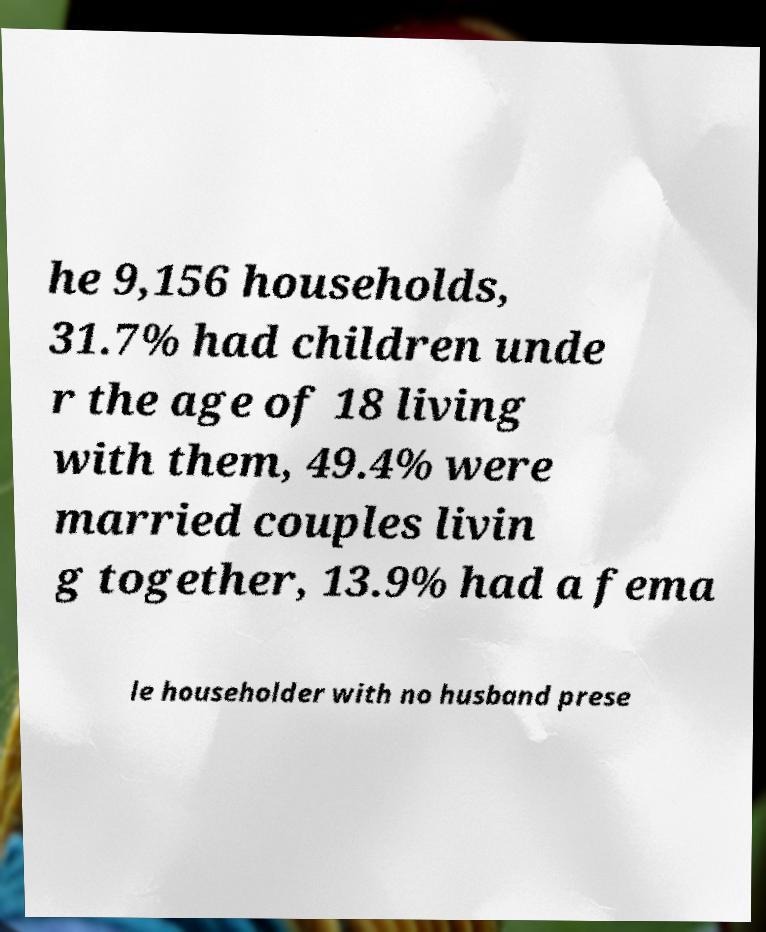Can you accurately transcribe the text from the provided image for me? he 9,156 households, 31.7% had children unde r the age of 18 living with them, 49.4% were married couples livin g together, 13.9% had a fema le householder with no husband prese 